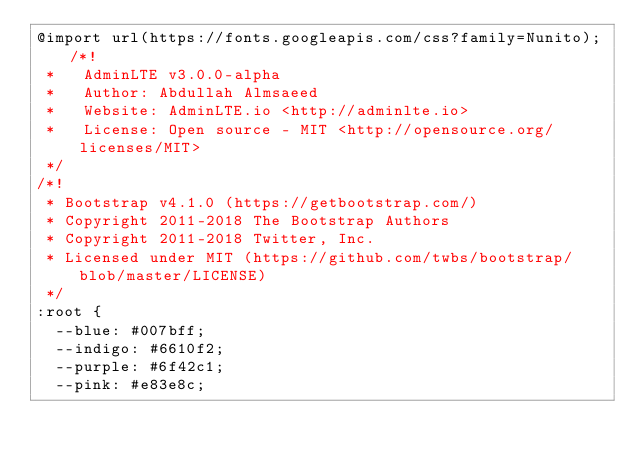Convert code to text. <code><loc_0><loc_0><loc_500><loc_500><_CSS_>@import url(https://fonts.googleapis.com/css?family=Nunito);/*!
 *   AdminLTE v3.0.0-alpha
 *   Author: Abdullah Almsaeed
 *	 Website: AdminLTE.io <http://adminlte.io>
 *   License: Open source - MIT <http://opensource.org/licenses/MIT>
 */
/*!
 * Bootstrap v4.1.0 (https://getbootstrap.com/)
 * Copyright 2011-2018 The Bootstrap Authors
 * Copyright 2011-2018 Twitter, Inc.
 * Licensed under MIT (https://github.com/twbs/bootstrap/blob/master/LICENSE)
 */
:root {
  --blue: #007bff;
  --indigo: #6610f2;
  --purple: #6f42c1;
  --pink: #e83e8c;</code> 